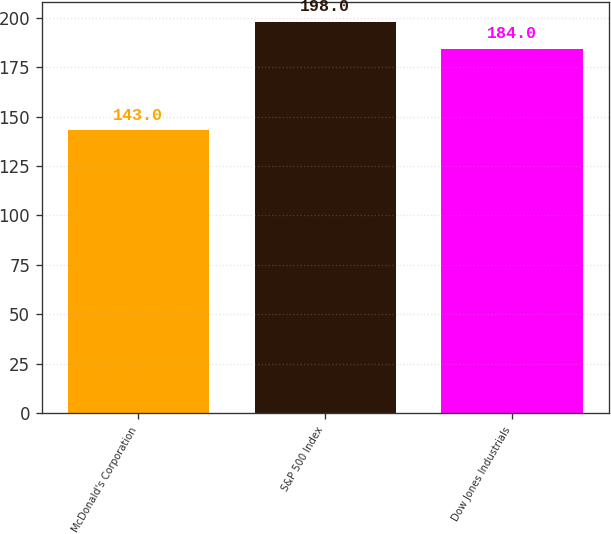<chart> <loc_0><loc_0><loc_500><loc_500><bar_chart><fcel>McDonald's Corporation<fcel>S&P 500 Index<fcel>Dow Jones Industrials<nl><fcel>143<fcel>198<fcel>184<nl></chart> 